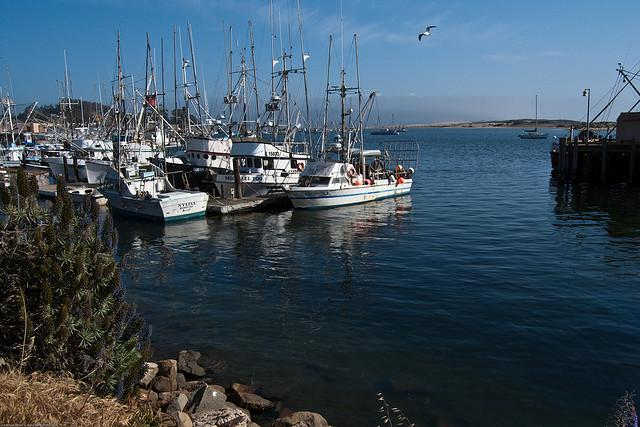Why are the boats stationary? docked 